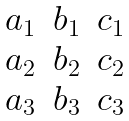Convert formula to latex. <formula><loc_0><loc_0><loc_500><loc_500>\begin{matrix} a _ { 1 } & b _ { 1 } & c _ { 1 } \\ a _ { 2 } & b _ { 2 } & c _ { 2 } \\ a _ { 3 } & b _ { 3 } & c _ { 3 } \end{matrix}</formula> 